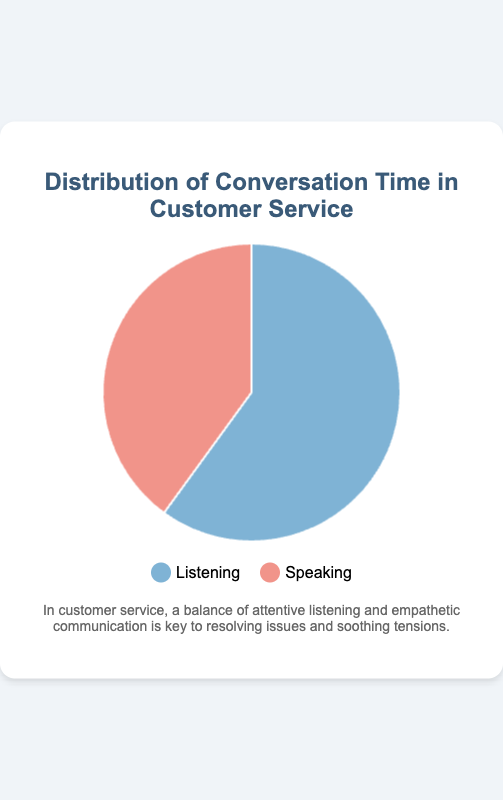What percentage of time is spent on listening? The pie chart shows that the slice representing listening accounts for 60% of the total time.
Answer: 60% What percentage of time is spent on speaking? The pie chart indicates that the slice representing speaking accounts for 40% of the total time.
Answer: 40% How does the time spent on listening compare to the time spent on speaking? The chart illustrates that the listening time is greater than the speaking time. Specifically, listening occupies 60% while speaking occupies 40%, showing that listening time is 20% more.
Answer: Listening is 20% more Which activity takes up more time, listening or speaking? By observing the pie chart, it is clear that the listening portion is larger than the speaking portion. Therefore, more time is spent on listening.
Answer: Listening Calculate the difference in time percentage between listening and speaking. Listening occupies 60% and speaking occupies 40%. The difference is calculated as 60% - 40%.
Answer: 20% If the total conversation time is 100 minutes, how many minutes are spent on listening and speaking respectively? If the total conversation time is 100 minutes: 
Listening = 60% of 100 minutes = 60 minutes 
Speaking = 40% of 100 minutes = 40 minutes
Answer: 60 minutes listening, 40 minutes speaking How does the color used for listening visually compare to the color used for speaking? The listening section is represented by a blue color, while the speaking section is represented by a pink color.
Answer: Blue vs. Pink Is the time more equally distributed or is there a clear dominance of one activity over the other? There is a clear dominance of listening over speaking as listening takes up 60% and speaking takes up 40% of the time, showing that listening takes significantly more time.
Answer: Clear dominance of listening If the slices represented positive feedback and negative feedback instead of listening and speaking, which activity would correspond to receiving more positive feedback based on the current proportions? Positive feedback would correspond to listening, as it occupies 60% of the chart, indicating more positive feedback.
Answer: Listening 